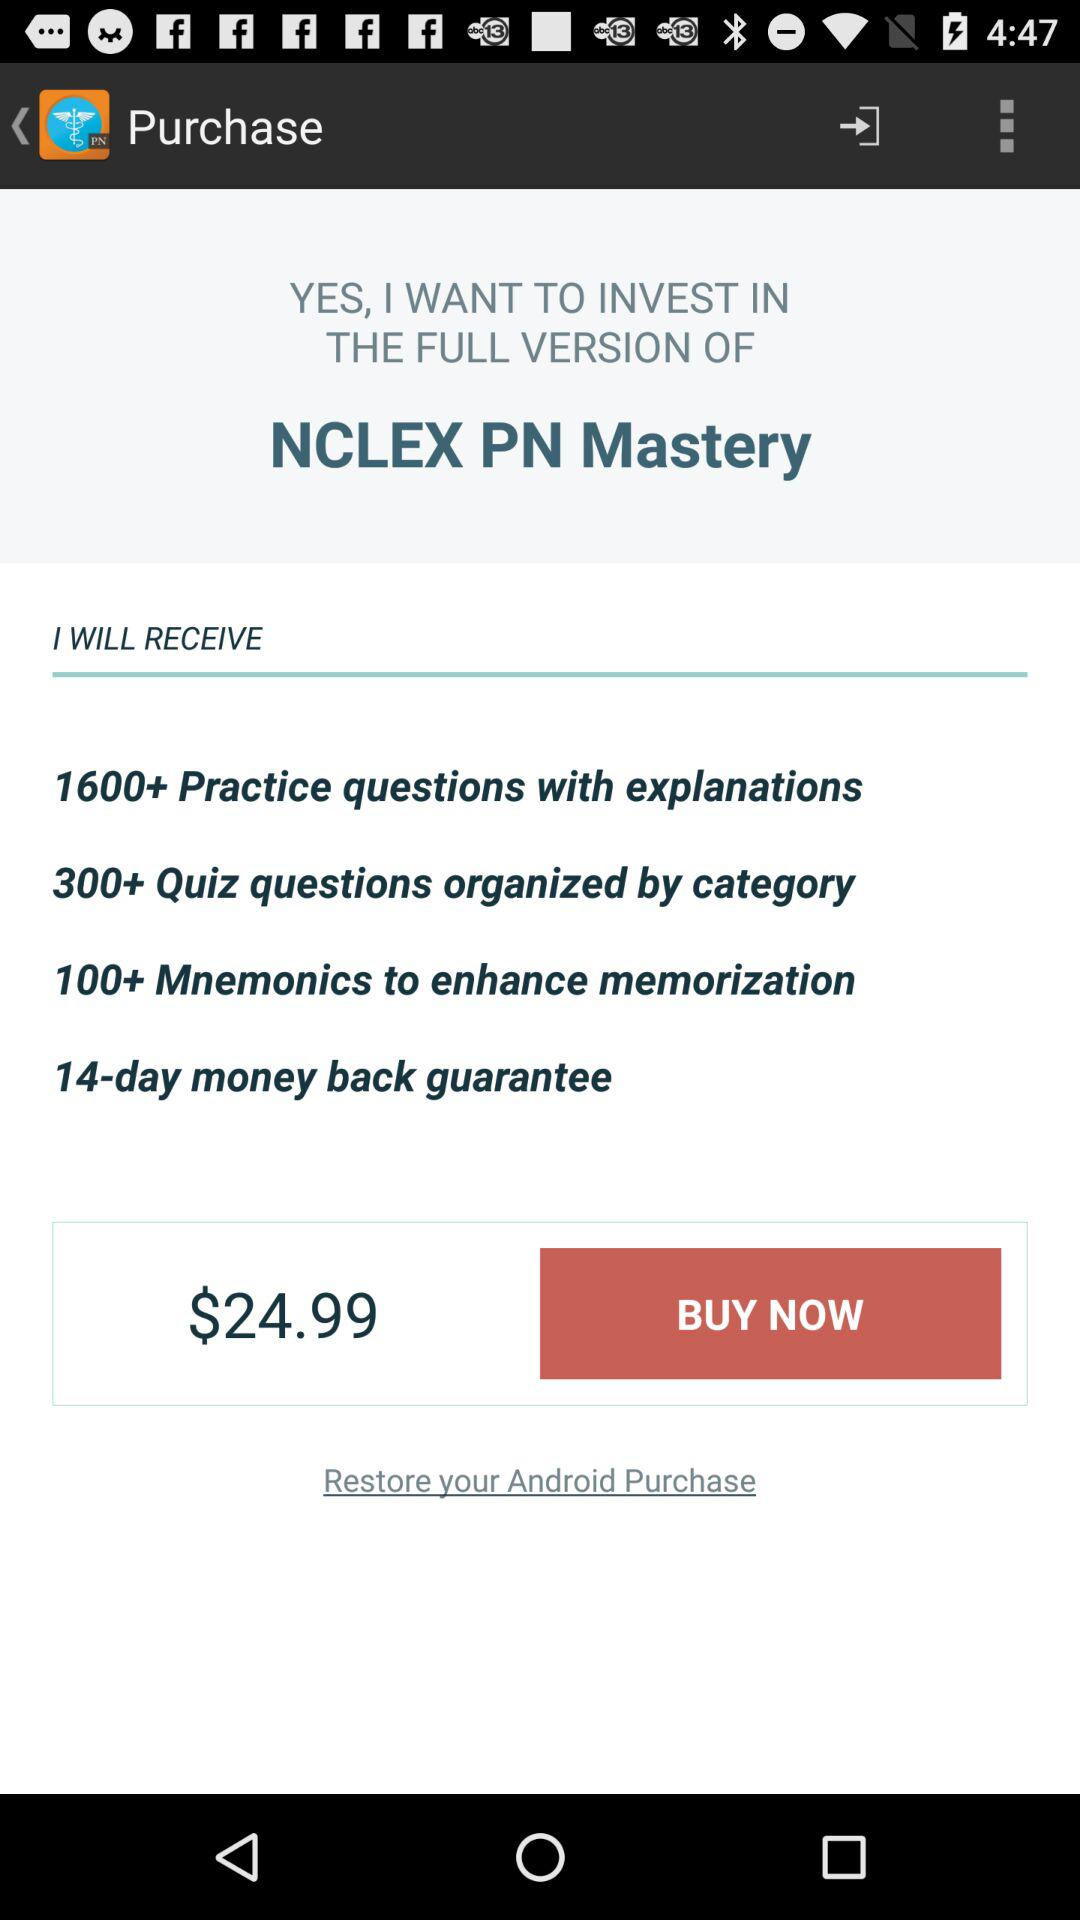What is the application name? The application name is "NCLEX PN Mastery". 